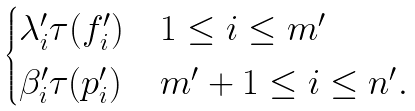<formula> <loc_0><loc_0><loc_500><loc_500>\begin{cases} \lambda ^ { \prime } _ { i } \tau ( f ^ { \prime } _ { i } ) & 1 \leq i \leq m ^ { \prime } \\ \beta ^ { \prime } _ { i } \tau ( p ^ { \prime } _ { i } ) & m ^ { \prime } + 1 \leq i \leq n ^ { \prime } . \end{cases}</formula> 